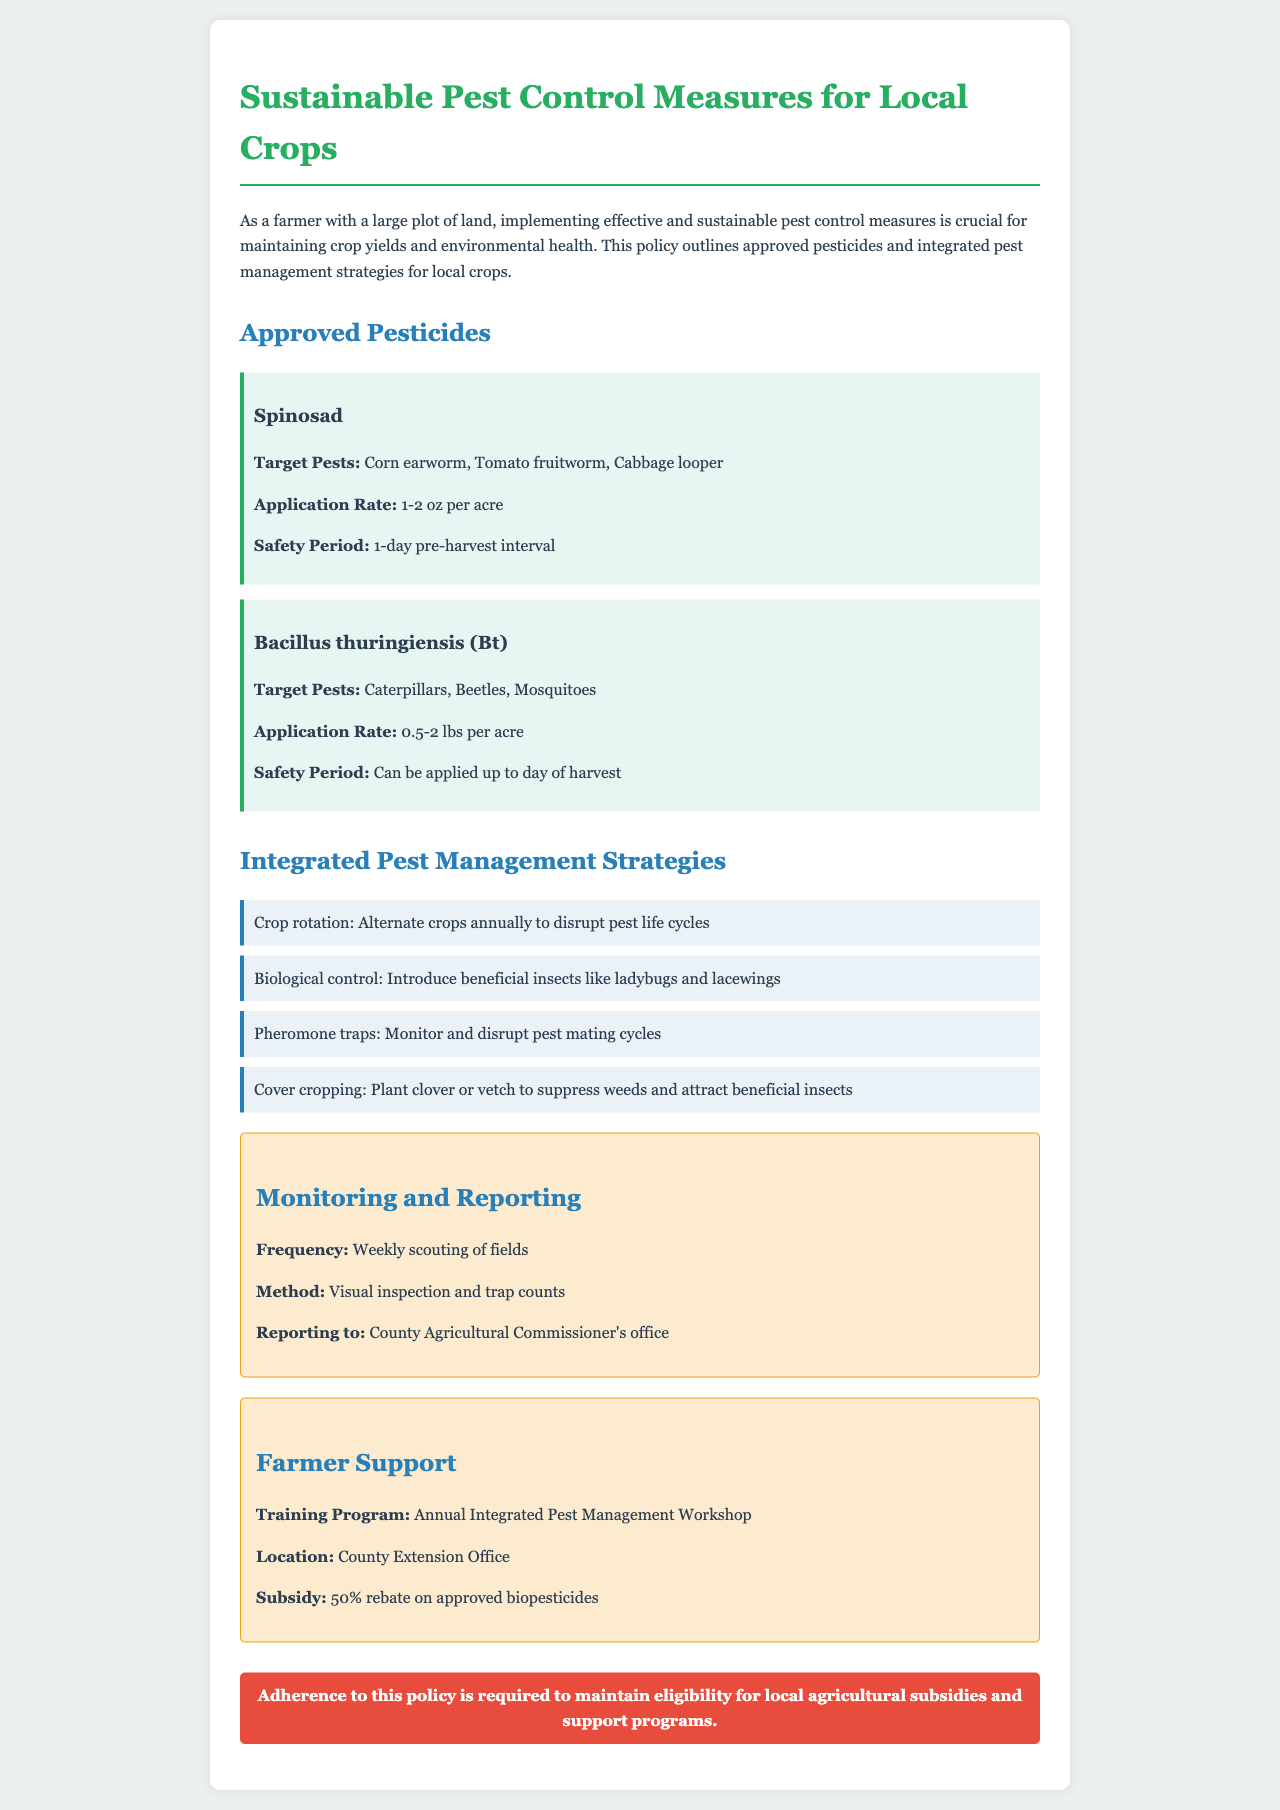What are the approved pesticides listed? The document lists two approved pesticides: Spinosad and Bacillus thuringiensis (Bt).
Answer: Spinosad, Bacillus thuringiensis (Bt) What is the application rate for Spinosad? The application rate for Spinosad is specified in the document as 1-2 oz per acre.
Answer: 1-2 oz per acre What is the safety period for Bacillus thuringiensis (Bt)? The safety period for Bacillus thuringiensis (Bt) is stated in the document as it can be applied up to the day of harvest.
Answer: Up to day of harvest What is one integrated pest management strategy mentioned? The document enumerates several strategies, one of which is crop rotation.
Answer: Crop rotation How often should fields be scouted according to the document? The document specifies the frequency of scouting as weekly.
Answer: Weekly What type of support is provided for farmers? The document mentions the training program offered for farmers is an Annual Integrated Pest Management Workshop.
Answer: Annual Integrated Pest Management Workshop What is the rebate percentage for approved biopesticides? The document explicitly states that there is a 50% rebate on approved biopesticides.
Answer: 50% To whom should monitoring reports be sent? According to the document, reports should be sent to the County Agricultural Commissioner's office.
Answer: County Agricultural Commissioner's office 